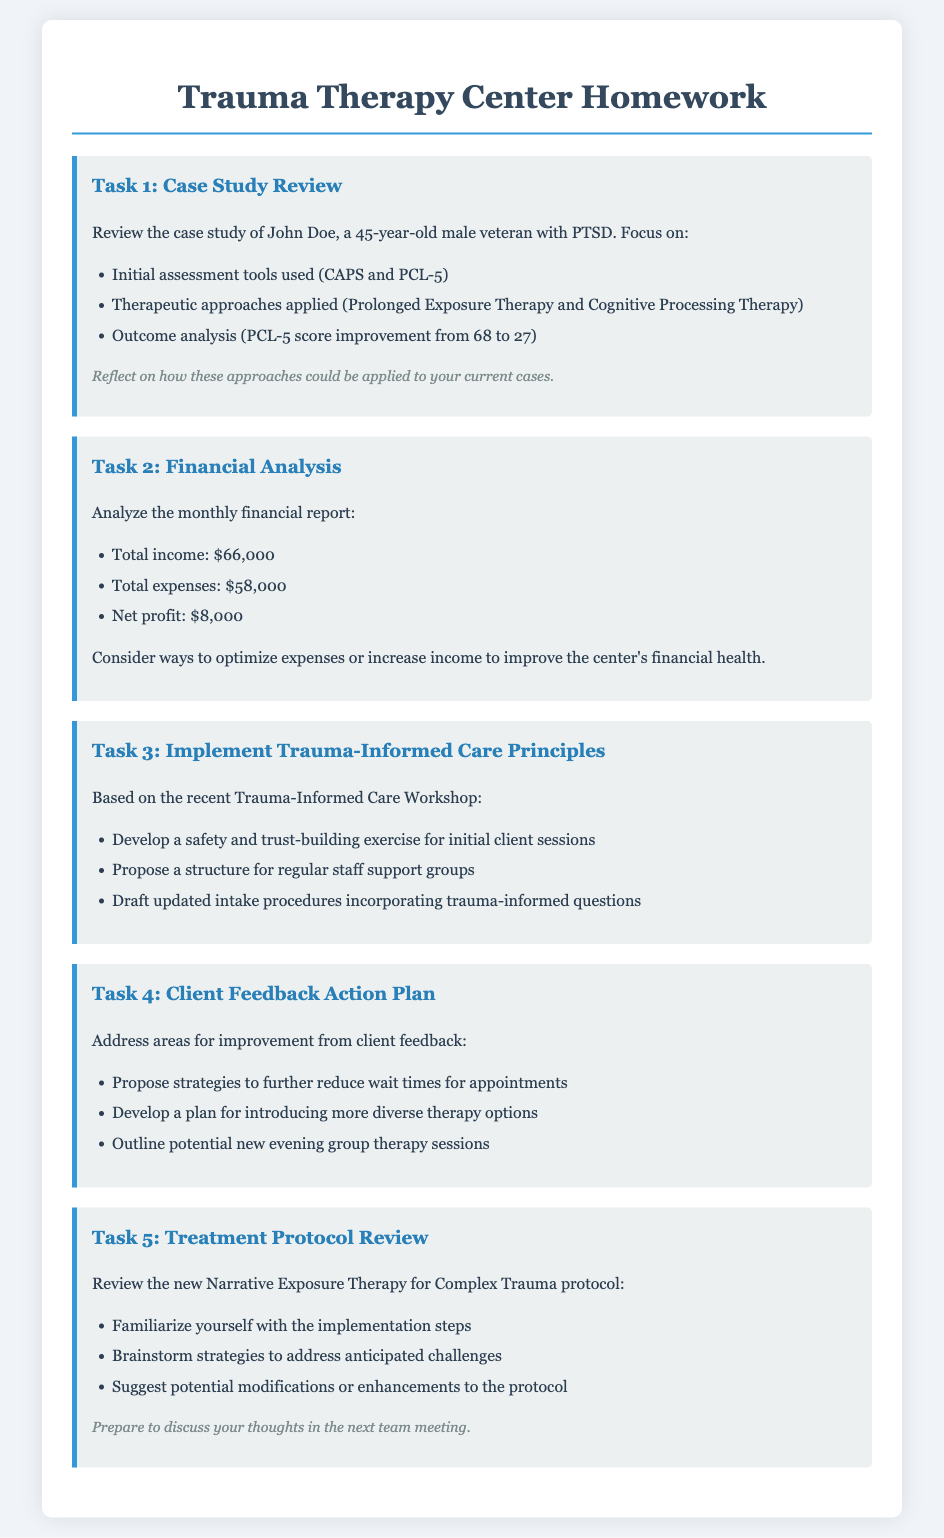What is the name of the case study reviewed? The case study focuses on John Doe, a specific patient treated at the center.
Answer: John Doe What was the initial PCL-5 score for the patient? The document specifies the initial PCL-5 score as part of the outcome analysis.
Answer: 68 What therapeutic approach is one of the methods used? The document lists Prolonged Exposure Therapy and Cognitive Processing Therapy as therapeutic approaches used.
Answer: Prolonged Exposure Therapy What is the net profit for the month? The net profit is calculated by subtracting total expenses from total income as mentioned in the financial report.
Answer: $8,000 What workshop did the staff recently attend? The document indicates that a Trauma-Informed Care Workshop was recently conducted for continuing education.
Answer: Trauma-Informed Care Workshop What is one proposed strategy to reduce wait times? The document outlines areas for improvement based on client feedback, and strategies are suggested to address these challenges.
Answer: Strategies to further reduce wait times Which new therapy protocol is being reviewed in the document? The document specifies the new therapy protocol being examined as part of the treatment protocol development.
Answer: Narrative Exposure Therapy for Complex Trauma What are the total expenses listed for the month? The total expenses for the month are specifically mentioned in the financial report section of the document.
Answer: $58,000 What should be prepared for the next team meeting? The document states that there is a requirement to discuss thoughts on the new protocol in the next team meeting.
Answer: Thoughts on the new protocol 